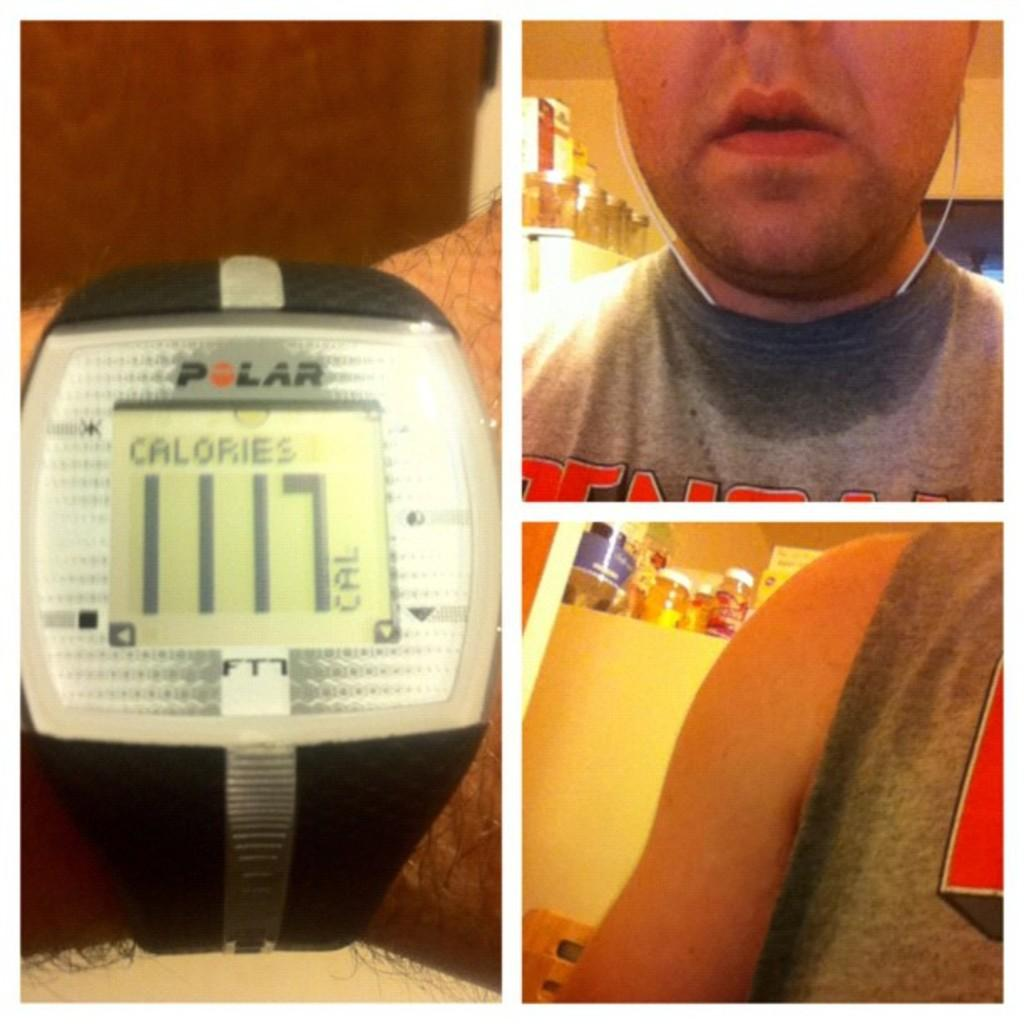<image>
Share a concise interpretation of the image provided. A man working out with a Polar watch which he burned 1117 calories. 